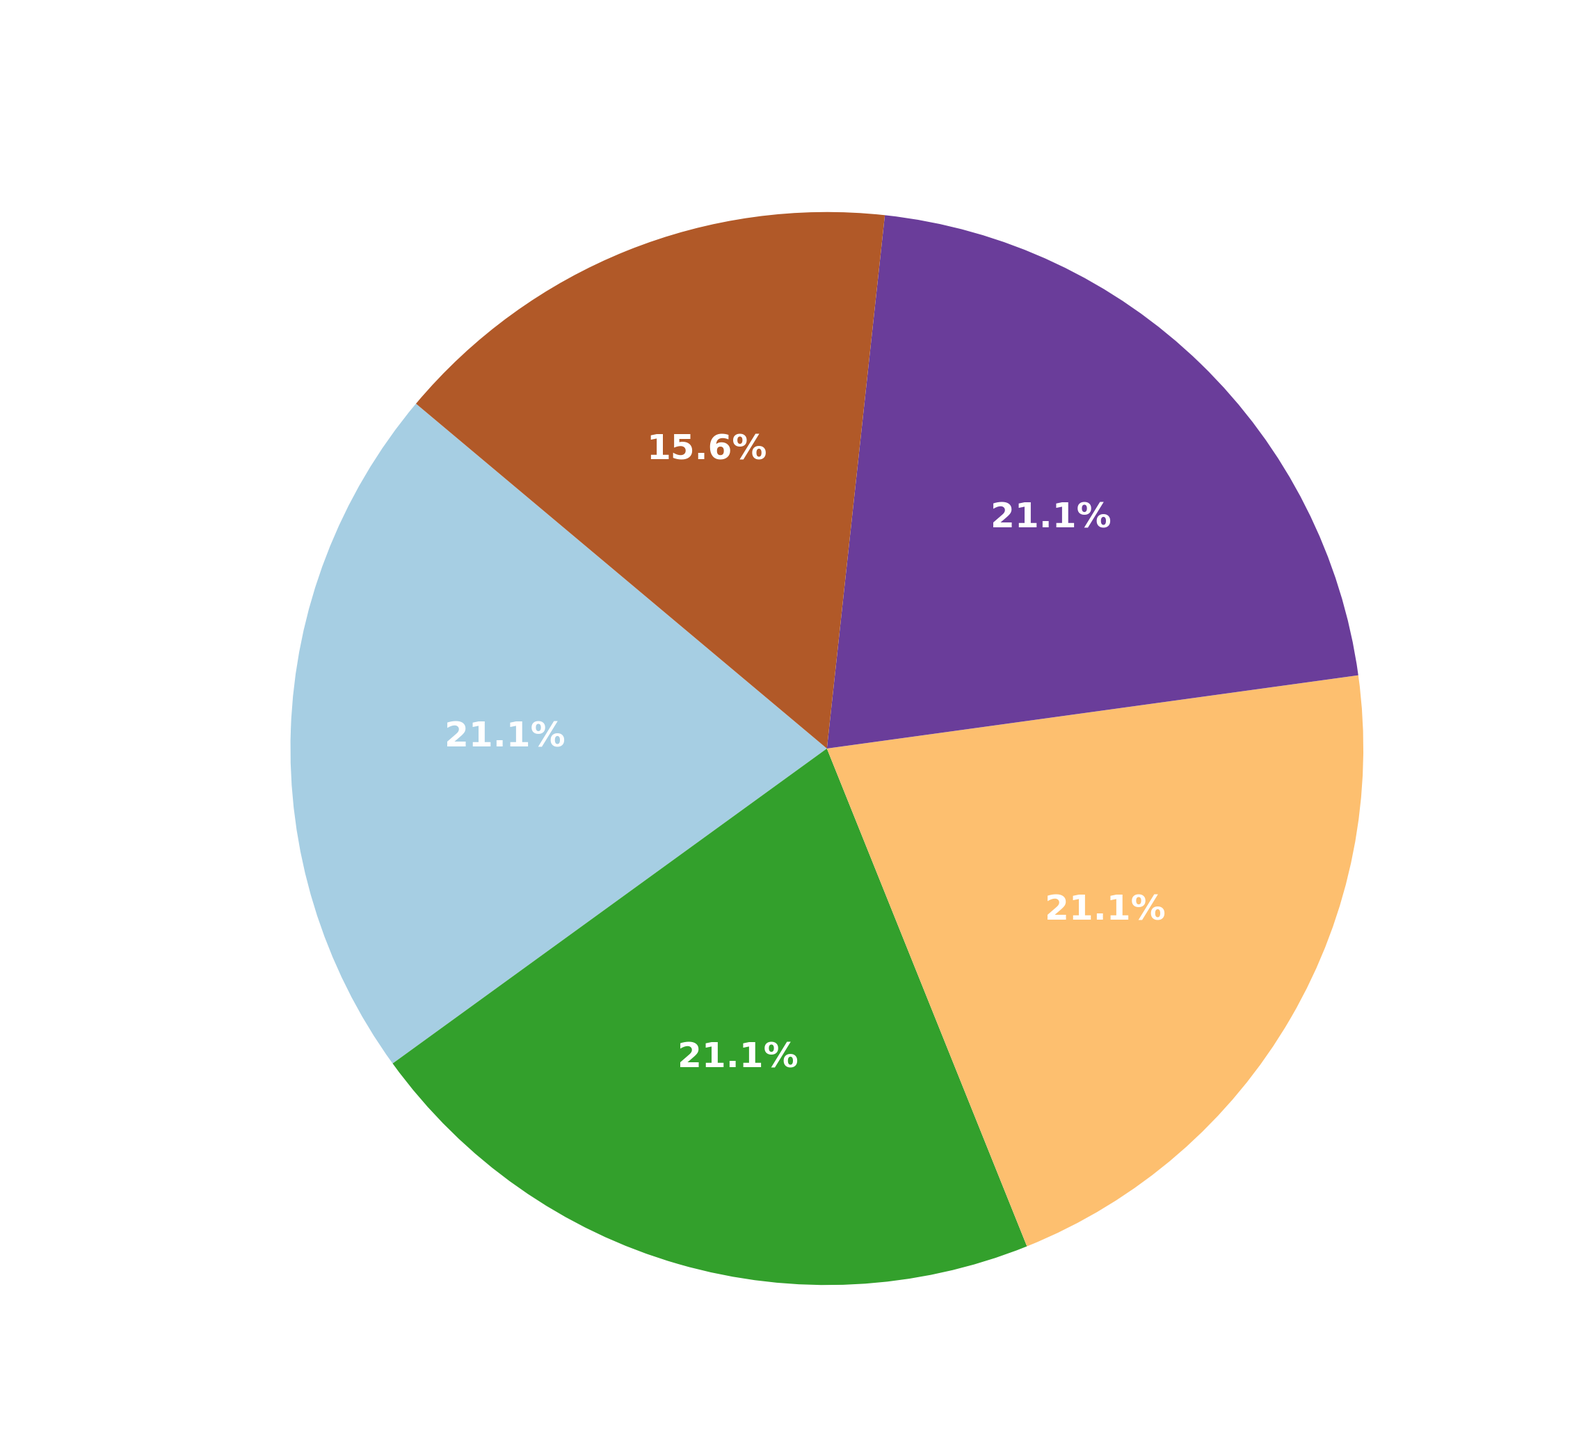Which platform has the highest usage percentage? By visually inspecting the pie chart, the platform with the largest slice represents the highest usage percentage.
Answer: TikTok Between Instagram and Facebook, which has a higher usage percentage? By comparing the sizes of the pie slices corresponding to Instagram and Facebook, we can see which one is larger.
Answer: Instagram What is the combined usage percentage of Snapchat and TikTok? Add the usage percentages of Snapchat and TikTok from the pie chart.
Answer: 64% (35% for Snapchat + 29% for TikTok) Compare the usage percentages of Instagram and Twitter. Which one is greater? By looking at the pie chart, identify the sizes of slices for Instagram and Twitter; the larger slice has the higher percentage.
Answer: Instagram By how much does TikTok's usage percentage exceed Snapchat's? Subtract Snapchat's percentage from TikTok's percentage according to the pie chart.
Answer: 5% (40% - 35%) Which platform has the smallest usage percentage, and what is it? Identify the smallest slice in the pie chart, which represents the platform with the smallest usage percentage.
Answer: TikTok (1%) What is the difference in usage percentage between the platform with the highest and the platform with the lowest usage? Subtract the smallest usage percentage from the highest by referring to the pie chart.
Answer: 39% (40% - 1%) What percentage of the pie chart is covered by the three platforms with the highest usage? Identify the three largest slices in the pie chart and sum their percentages.
Answer: 100% (40% for TikTok, 35% for Snapchat, and 29% for Instagram) Which platform’s usage is greater, Facebook or Snapchat? Compare the slices for Facebook and Snapchat in the pie chart and determine the larger one.
Answer: Snapchat Compare the slice colors for Twitter and Snapchat. Which one is darker? Visually inspect the colors of the slices representing Twitter and Snapchat and compare their shades.
Answer: Twitter 